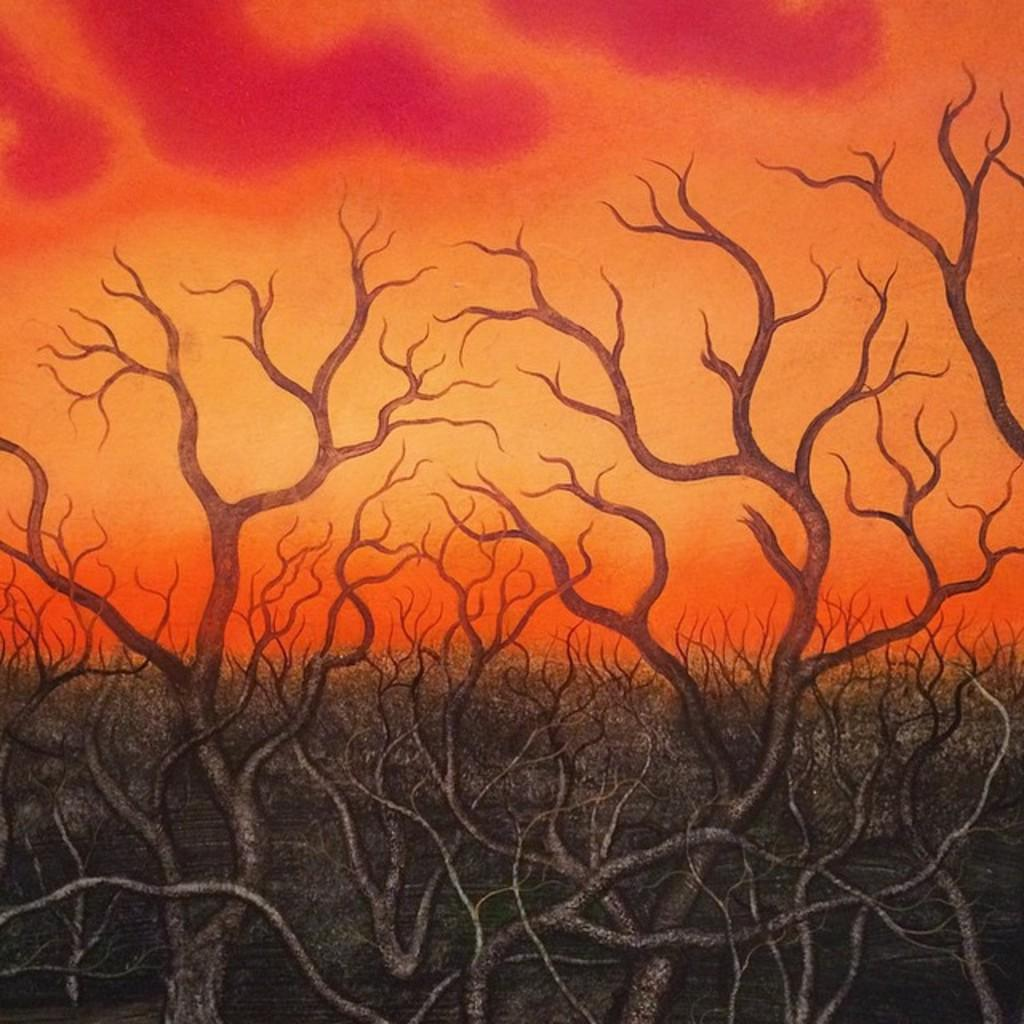What is depicted in the paintings in the image? There are paintings of roots and branches in the image. What colors are used in the background of the paintings? The background of the paintings has an orange and pink shade. What type of scent can be detected from the bushes in the image? There are no bushes present in the image, only paintings of roots and branches. How does the throat of the person in the image appear? There is no person present in the image, only paintings of roots and branches. 